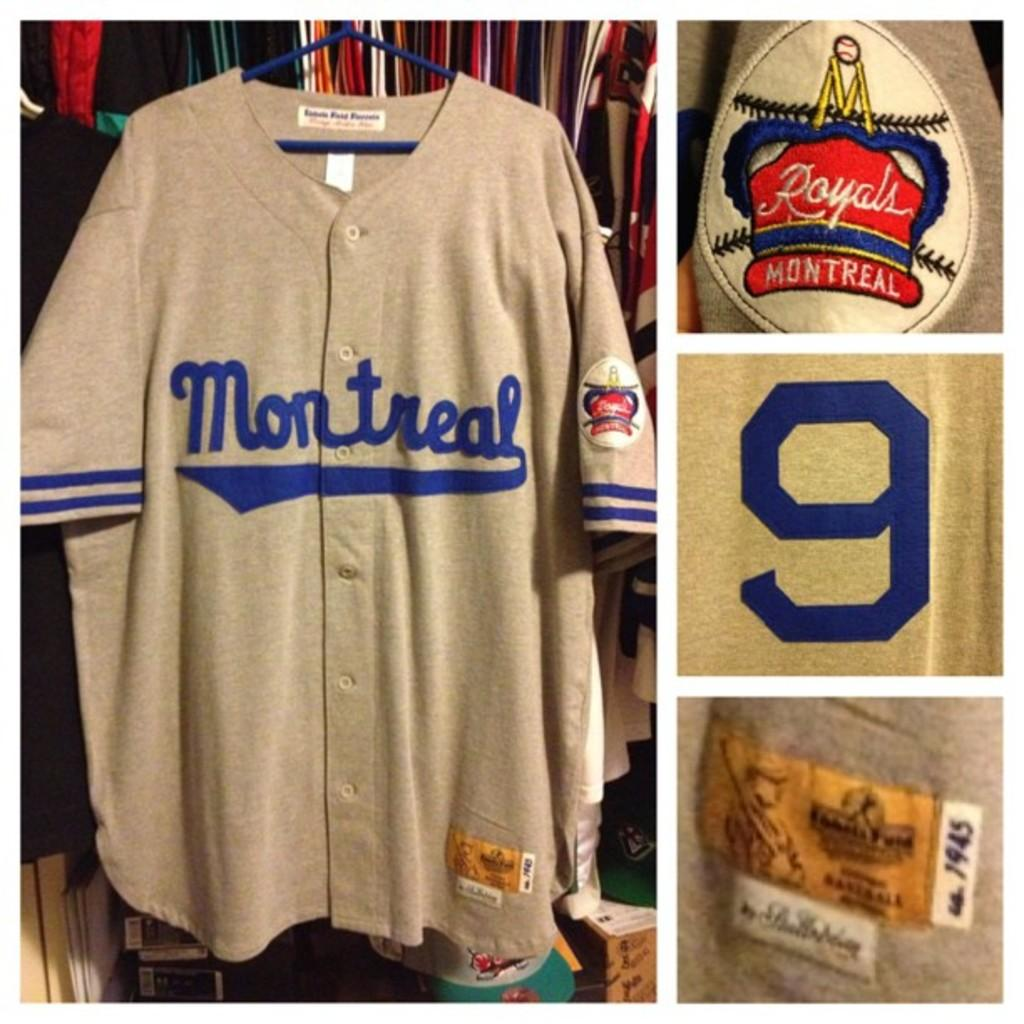What type of clothing item is in the image? There is a t-shirt in the image. How is the t-shirt positioned in the image? The t-shirt is on a hanger. What text is written on the t-shirt? The t-shirt has "Royal" written on the hand sleeve. What number is on the t-shirt? The t-shirt is a number 9 jersey. What activity is the t-shirt participating in within the image? The t-shirt is not participating in any activity; it is an inanimate object hanging on a hanger. 